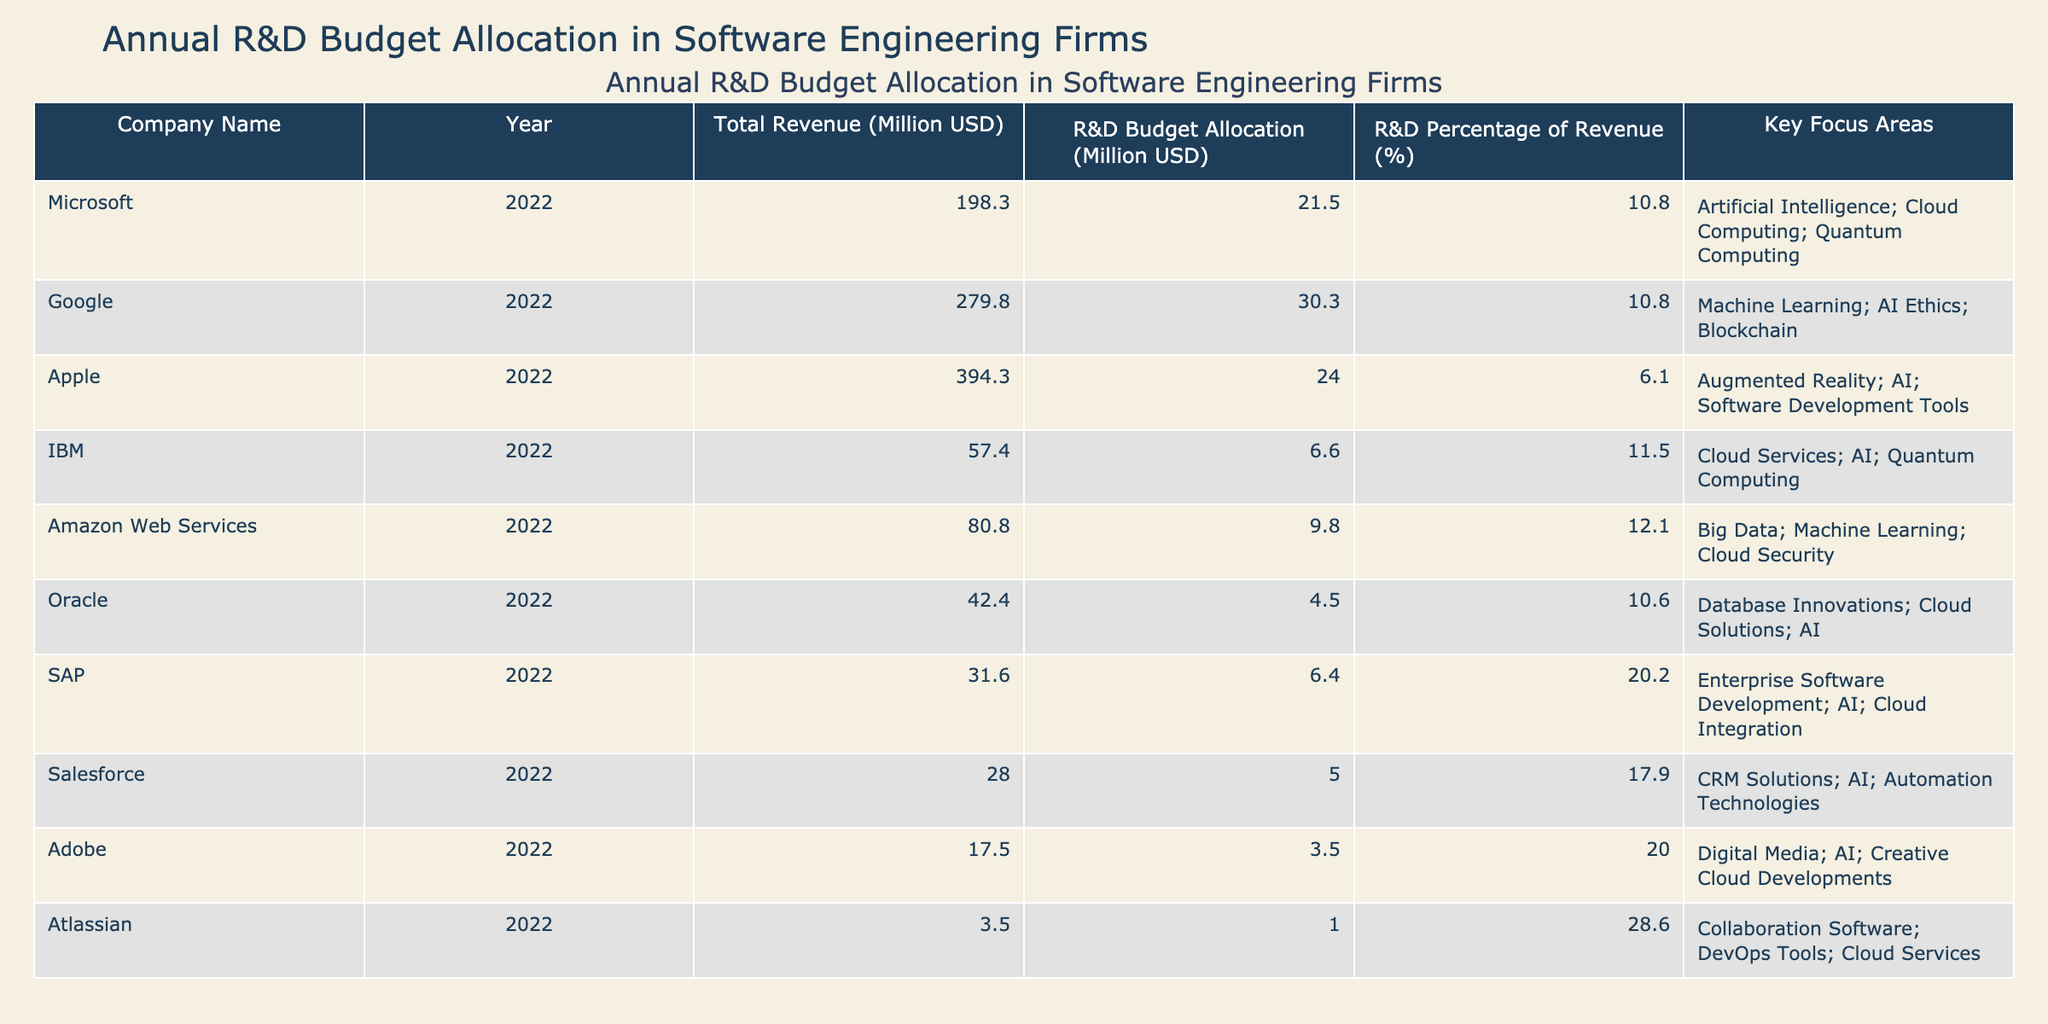What is the R&D budget allocation for Google in 2022? The table lists Google's R&D budget allocation directly as 30.3 million USD for the year 2022.
Answer: 30.3 million USD Which company has the highest R&D percentage of revenue? By reviewing the R&D percentage of revenue for each company, Atlassian shows the highest percentage at 28.6%.
Answer: Atlassian What is the combined R&D budget allocation for Microsoft, Amazon Web Services, and IBM? The combined R&D budget allocation is calculated as follows: 21.5 (Microsoft) + 9.8 (Amazon Web Services) + 6.6 (IBM) = 37.9 million USD.
Answer: 37.9 million USD Is the R&D budget allocation for Adobe higher than for Oracle? The R&D budget allocation for Adobe is 3.5 million USD, while Oracle's is 4.5 million USD, thus, Adobe's is lower.
Answer: No What is the average R&D budget allocation of the listed companies? We total the R&D budget allocations: 21.5 + 30.3 + 24.0 + 6.6 + 9.8 + 4.5 + 6.4 + 5.0 + 3.5 + 1.0 = 112.2 million USD. Since there are 10 companies, the average is 112.2 / 10 = 11.22 million USD.
Answer: 11.2 million USD Which company spent the least on R&D in 2022? By inspecting the R&D budget allocations, Atlassian spent the least at 1.0 million USD.
Answer: Atlassian If we only consider companies that focus on AI, what is the total R&D budget allocation for those companies? The companies focusing on AI are Microsoft (21.5), Google (30.3), IBM (6.6), Oracle (4.5), SAP (6.4), Salesforce (5.0), Adobe (3.5), and Atlassian (1.0). The total allocation is 21.5 + 30.3 + 6.6 + 4.5 + 6.4 + 5.0 + 3.5 + 1.0 = 78.8 million USD.
Answer: 78.8 million USD Which company's R&D budget is less than 10% of its total revenue? Looking at the R&D percentages, Apple has an R&D percentage of 6.1%, which is less than 10%.
Answer: Apple How many companies have an R&D percentage of revenue greater than 10%? The companies with an R&D percentage greater than 10% are Microsoft (10.8), Google (10.8), IBM (11.5), Amazon Web Services (12.1), SAP (20.2), Salesforce (17.9), Adobe (20.0), and Atlassian (28.6). This totals to 8 companies.
Answer: 8 companies What is the difference in R&D budget allocation between the highest and lowest spending companies? The highest R&D budget allocation is from Google at 30.3 million and the lowest is Atlassian at 1.0 million. The difference is 30.3 - 1.0 = 29.3 million USD.
Answer: 29.3 million USD 